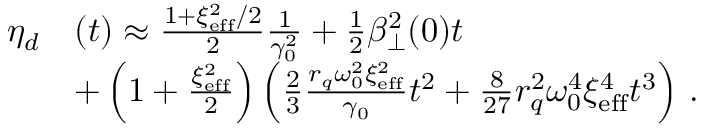<formula> <loc_0><loc_0><loc_500><loc_500>\begin{array} { r l } { \eta _ { d } } & { ( t ) \approx \frac { 1 + \xi _ { e f f } ^ { 2 } / 2 } { 2 } \frac { 1 } { \gamma _ { 0 } ^ { 2 } } + \frac { 1 } { 2 } \beta _ { \perp } ^ { 2 } ( 0 ) t } \\ & { + \left ( 1 + \frac { \xi _ { e f f } ^ { 2 } } { 2 } \right ) \left ( \frac { 2 } { 3 } \frac { r _ { q } \omega _ { 0 } ^ { 2 } \xi _ { e f f } ^ { 2 } } { \gamma _ { 0 } } t ^ { 2 } + \frac { 8 } { 2 7 } r _ { q } ^ { 2 } \omega _ { 0 } ^ { 4 } \xi _ { e f f } ^ { 4 } t ^ { 3 } \right ) \, . } \end{array}</formula> 